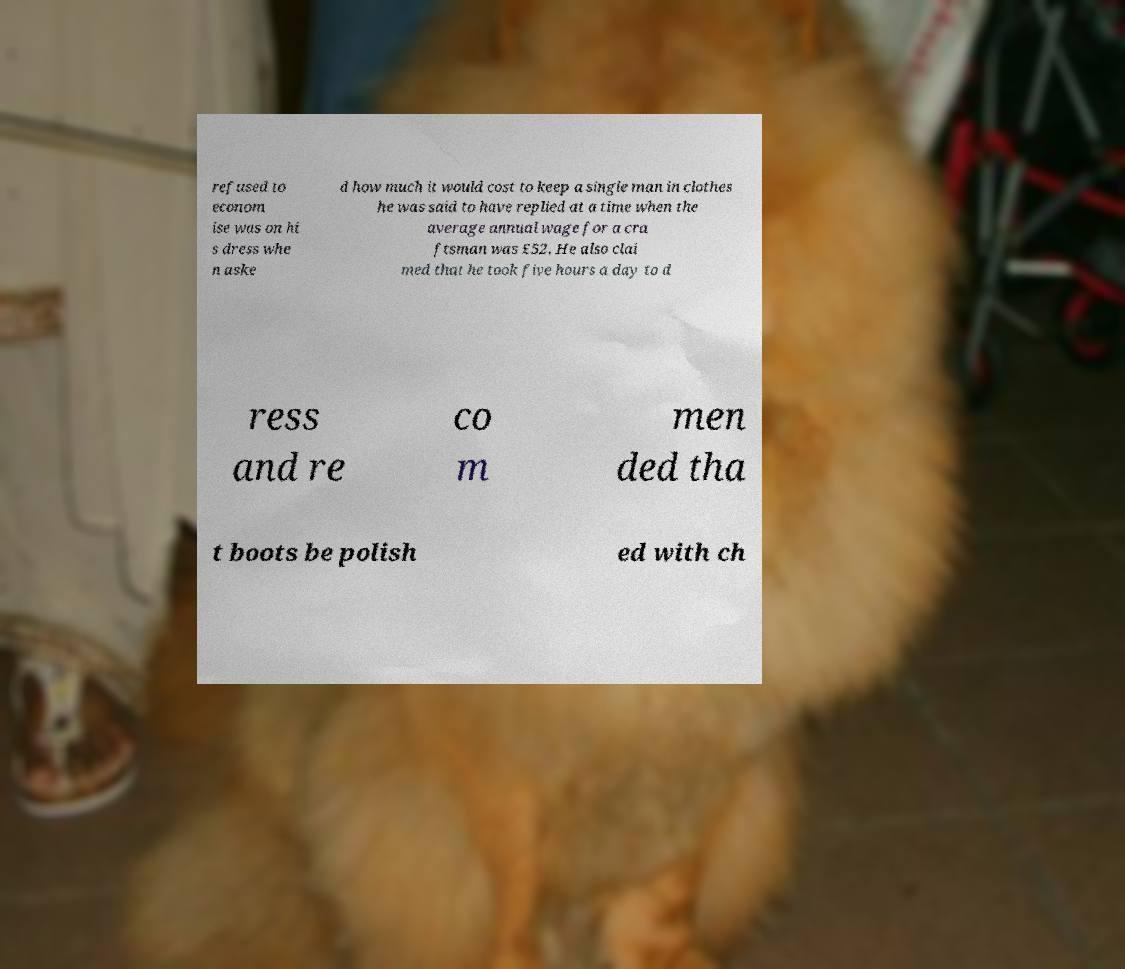I need the written content from this picture converted into text. Can you do that? refused to econom ise was on hi s dress whe n aske d how much it would cost to keep a single man in clothes he was said to have replied at a time when the average annual wage for a cra ftsman was £52. He also clai med that he took five hours a day to d ress and re co m men ded tha t boots be polish ed with ch 